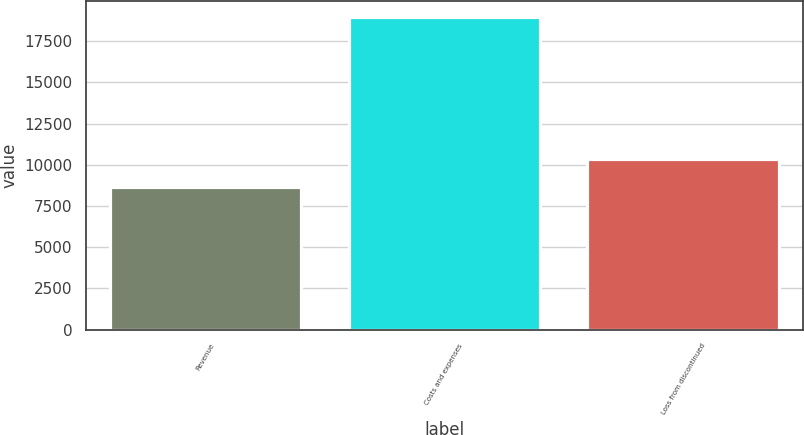<chart> <loc_0><loc_0><loc_500><loc_500><bar_chart><fcel>Revenue<fcel>Costs and expenses<fcel>Loss from discontinued<nl><fcel>8646<fcel>18998<fcel>10352<nl></chart> 